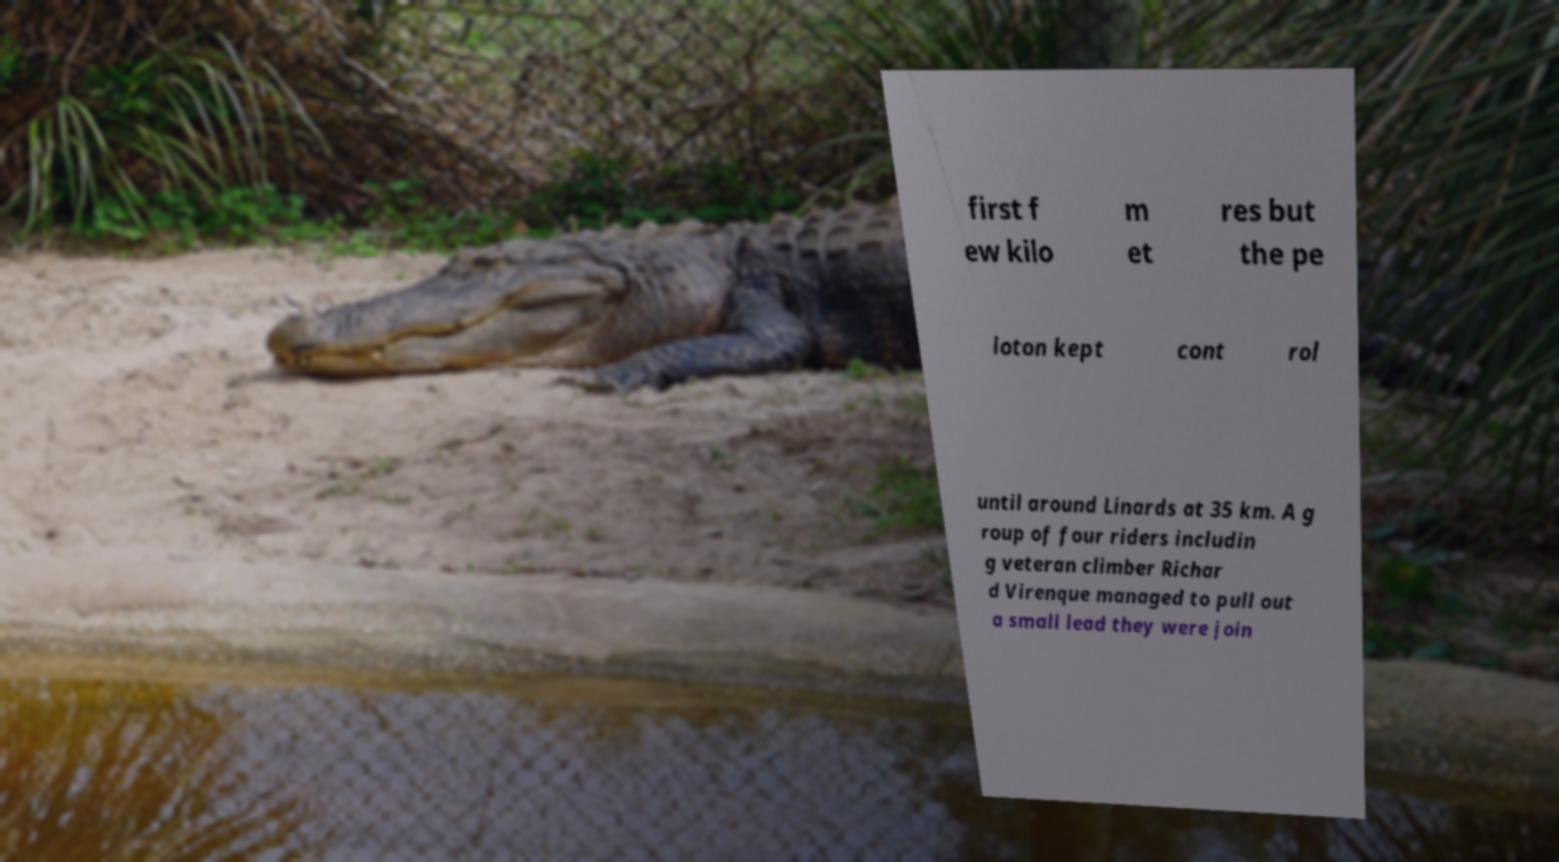Can you accurately transcribe the text from the provided image for me? first f ew kilo m et res but the pe loton kept cont rol until around Linards at 35 km. A g roup of four riders includin g veteran climber Richar d Virenque managed to pull out a small lead they were join 